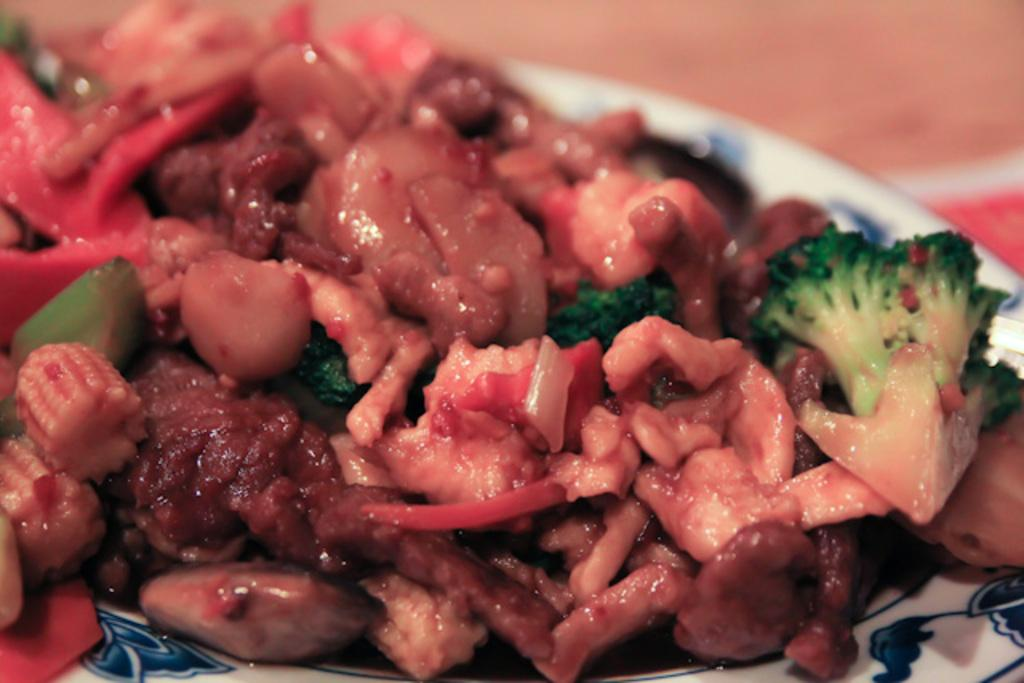What is the color of the plate in the image? The plate in the image is white. What vegetables are on the plate? The plate contains broccoli and baby corns. Are there any other food items on the plate besides the vegetables? Yes, there are other food items on the plate. What type of glove is being used to serve the food on the plate? There is no glove present in the image; the food is likely being served with utensils or by hand. 